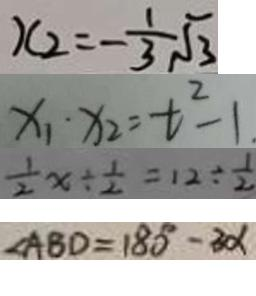Convert formula to latex. <formula><loc_0><loc_0><loc_500><loc_500>x _ { 2 } = - \frac { 1 } { 3 } \sqrt { 3 } 
 x _ { 1 } \cdot x _ { 2 } = t ^ { 2 } - 1 . 
 \frac { 1 } { 2 } x \div \frac { 1 } { 2 } = 1 2 \div \frac { 1 } { 2 } 
 \angle A B D = 1 8 0 ^ { \circ } - 3 \alpha</formula> 